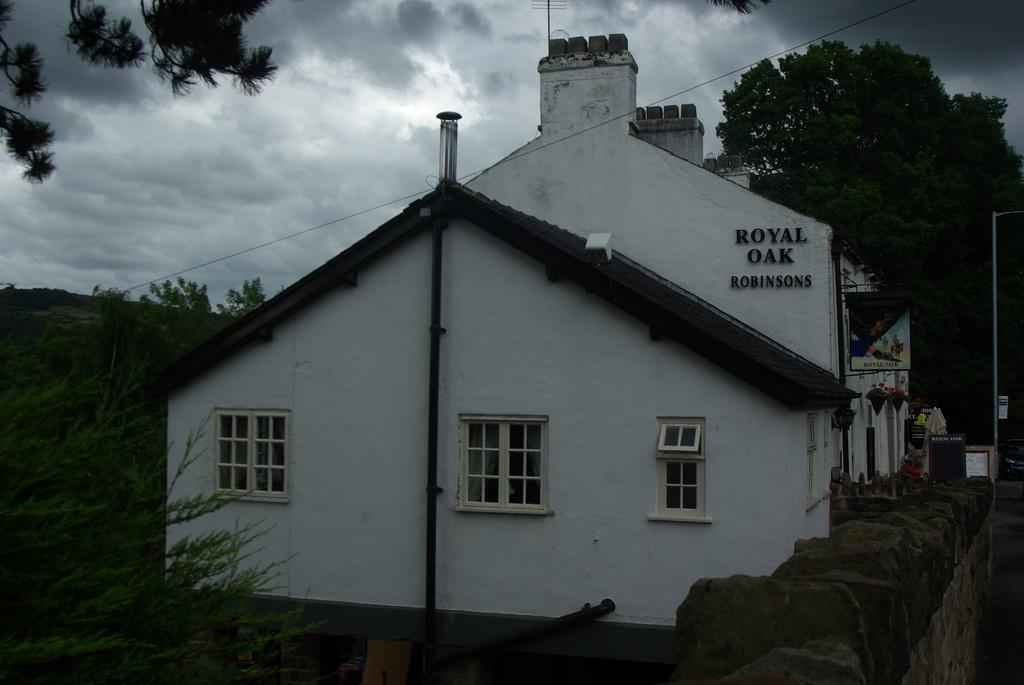What type of structure is visible in the image? There is a house in the image. Can you describe anything written or displayed on the house? There is text on the right side of the wall in the image. What can be seen in the background of the image? There are trees and clouds visible in the background of the image. What type of day is depicted in the image? The provided facts do not mention any specific day or weather conditions, so it cannot be determined from the image. 